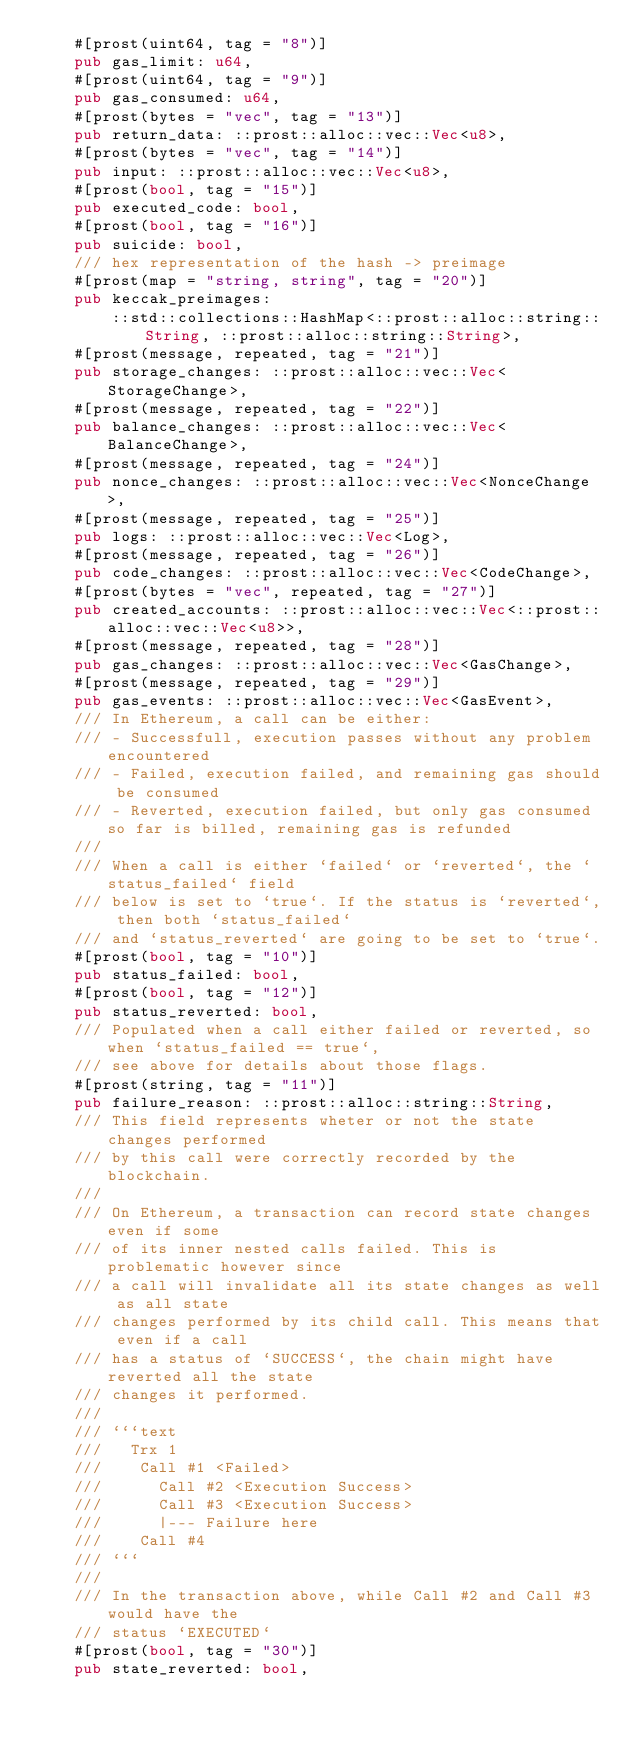<code> <loc_0><loc_0><loc_500><loc_500><_Rust_>    #[prost(uint64, tag = "8")]
    pub gas_limit: u64,
    #[prost(uint64, tag = "9")]
    pub gas_consumed: u64,
    #[prost(bytes = "vec", tag = "13")]
    pub return_data: ::prost::alloc::vec::Vec<u8>,
    #[prost(bytes = "vec", tag = "14")]
    pub input: ::prost::alloc::vec::Vec<u8>,
    #[prost(bool, tag = "15")]
    pub executed_code: bool,
    #[prost(bool, tag = "16")]
    pub suicide: bool,
    /// hex representation of the hash -> preimage
    #[prost(map = "string, string", tag = "20")]
    pub keccak_preimages:
        ::std::collections::HashMap<::prost::alloc::string::String, ::prost::alloc::string::String>,
    #[prost(message, repeated, tag = "21")]
    pub storage_changes: ::prost::alloc::vec::Vec<StorageChange>,
    #[prost(message, repeated, tag = "22")]
    pub balance_changes: ::prost::alloc::vec::Vec<BalanceChange>,
    #[prost(message, repeated, tag = "24")]
    pub nonce_changes: ::prost::alloc::vec::Vec<NonceChange>,
    #[prost(message, repeated, tag = "25")]
    pub logs: ::prost::alloc::vec::Vec<Log>,
    #[prost(message, repeated, tag = "26")]
    pub code_changes: ::prost::alloc::vec::Vec<CodeChange>,
    #[prost(bytes = "vec", repeated, tag = "27")]
    pub created_accounts: ::prost::alloc::vec::Vec<::prost::alloc::vec::Vec<u8>>,
    #[prost(message, repeated, tag = "28")]
    pub gas_changes: ::prost::alloc::vec::Vec<GasChange>,
    #[prost(message, repeated, tag = "29")]
    pub gas_events: ::prost::alloc::vec::Vec<GasEvent>,
    /// In Ethereum, a call can be either:
    /// - Successfull, execution passes without any problem encountered
    /// - Failed, execution failed, and remaining gas should be consumed
    /// - Reverted, execution failed, but only gas consumed so far is billed, remaining gas is refunded
    ///
    /// When a call is either `failed` or `reverted`, the `status_failed` field
    /// below is set to `true`. If the status is `reverted`, then both `status_failed`
    /// and `status_reverted` are going to be set to `true`.
    #[prost(bool, tag = "10")]
    pub status_failed: bool,
    #[prost(bool, tag = "12")]
    pub status_reverted: bool,
    /// Populated when a call either failed or reverted, so when `status_failed == true`,
    /// see above for details about those flags.
    #[prost(string, tag = "11")]
    pub failure_reason: ::prost::alloc::string::String,
    /// This field represents wheter or not the state changes performed
    /// by this call were correctly recorded by the blockchain.
    ///
    /// On Ethereum, a transaction can record state changes even if some
    /// of its inner nested calls failed. This is problematic however since
    /// a call will invalidate all its state changes as well as all state
    /// changes performed by its child call. This means that even if a call
    /// has a status of `SUCCESS`, the chain might have reverted all the state
    /// changes it performed.
    ///
    /// ```text
    ///   Trx 1
    ///    Call #1 <Failed>
    ///      Call #2 <Execution Success>
    ///      Call #3 <Execution Success>
    ///      |--- Failure here
    ///    Call #4
    /// ```
    ///
    /// In the transaction above, while Call #2 and Call #3 would have the
    /// status `EXECUTED`
    #[prost(bool, tag = "30")]
    pub state_reverted: bool,</code> 